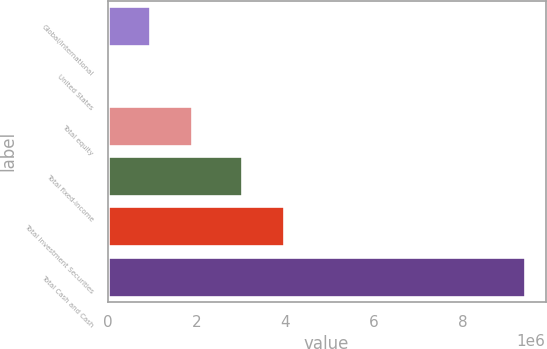<chart> <loc_0><loc_0><loc_500><loc_500><bar_chart><fcel>Global/international<fcel>United States<fcel>Total equity<fcel>Total fixed-income<fcel>Total Investment Securities<fcel>Total Cash and Cash<nl><fcel>964921<fcel>28873<fcel>1.90097e+06<fcel>3.02879e+06<fcel>3.96484e+06<fcel>9.38935e+06<nl></chart> 